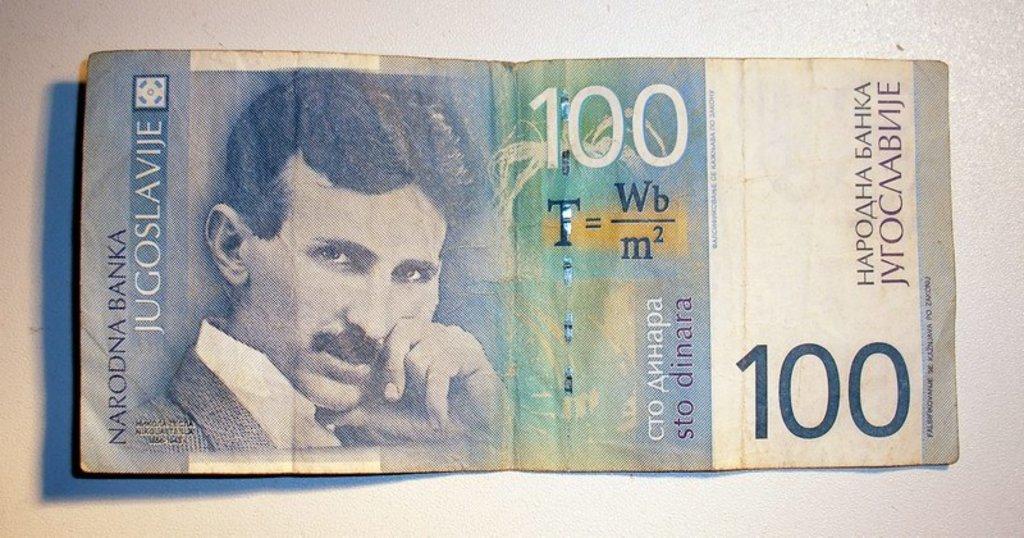How would you summarize this image in a sentence or two? In this picture we can see a person, some text and numbers on a currency note. This note is visible on a white surface. 